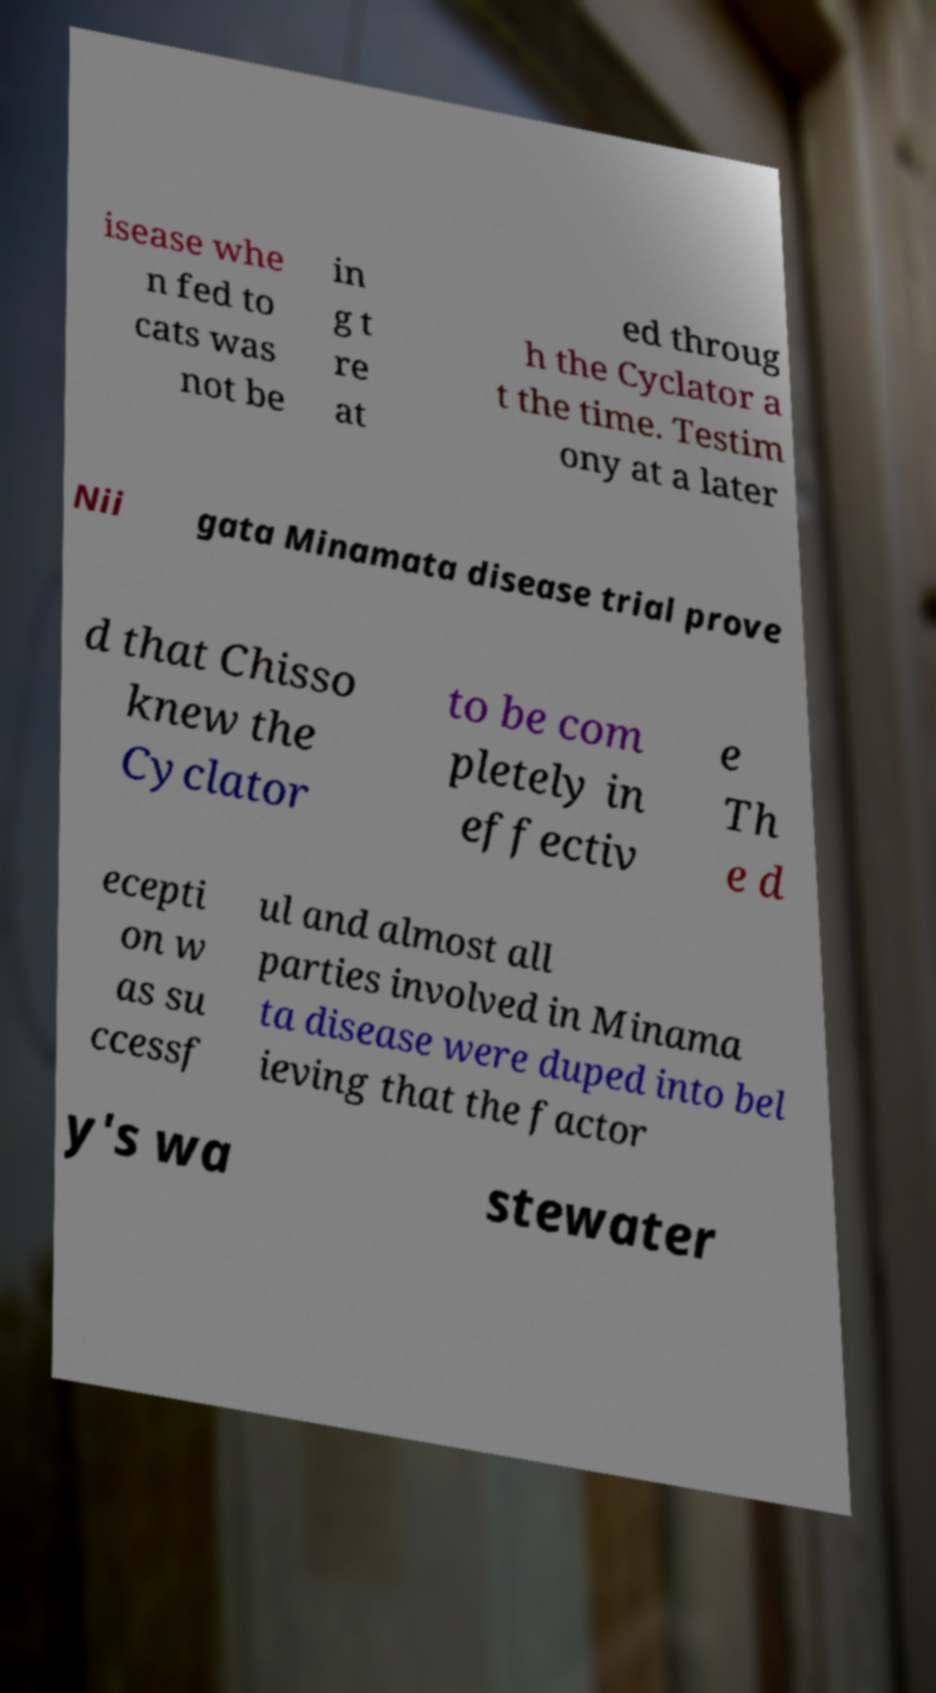Could you extract and type out the text from this image? isease whe n fed to cats was not be in g t re at ed throug h the Cyclator a t the time. Testim ony at a later Nii gata Minamata disease trial prove d that Chisso knew the Cyclator to be com pletely in effectiv e Th e d ecepti on w as su ccessf ul and almost all parties involved in Minama ta disease were duped into bel ieving that the factor y's wa stewater 